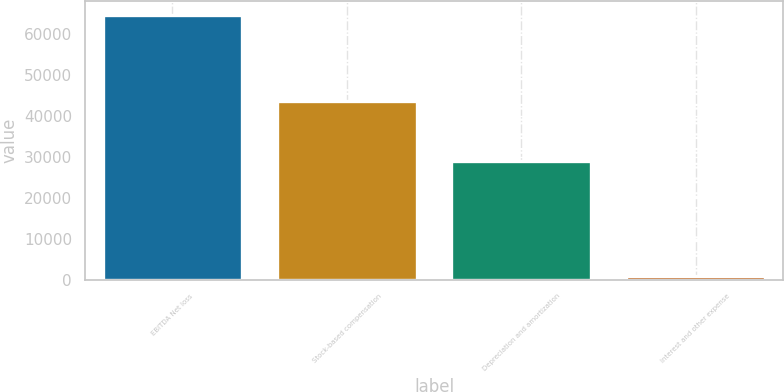<chart> <loc_0><loc_0><loc_500><loc_500><bar_chart><fcel>EBITDA Net loss<fcel>Stock-based compensation<fcel>Depreciation and amortization<fcel>Interest and other expense<nl><fcel>64601<fcel>43602<fcel>29023<fcel>909<nl></chart> 